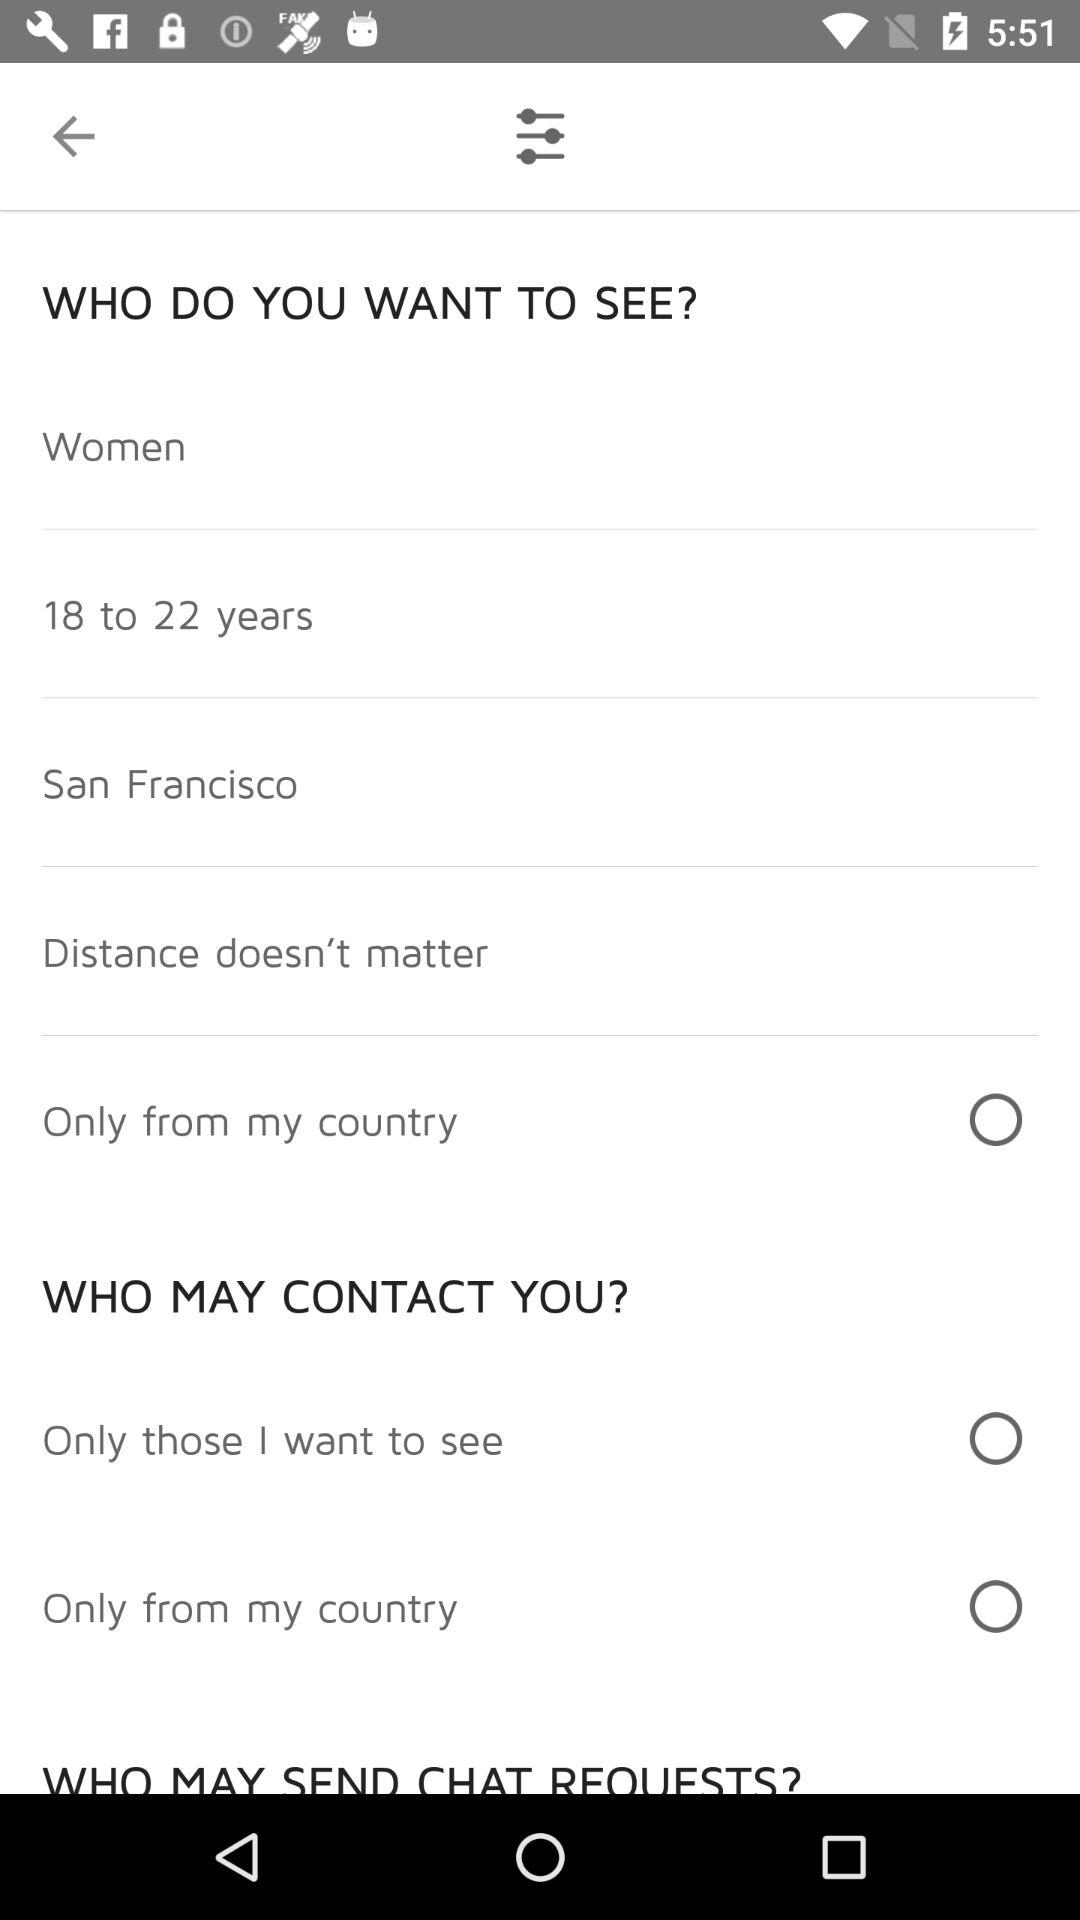Which age range is selected for the person the user wants to see? The user wants to see people whose ages range from 18 to 22 years old. 